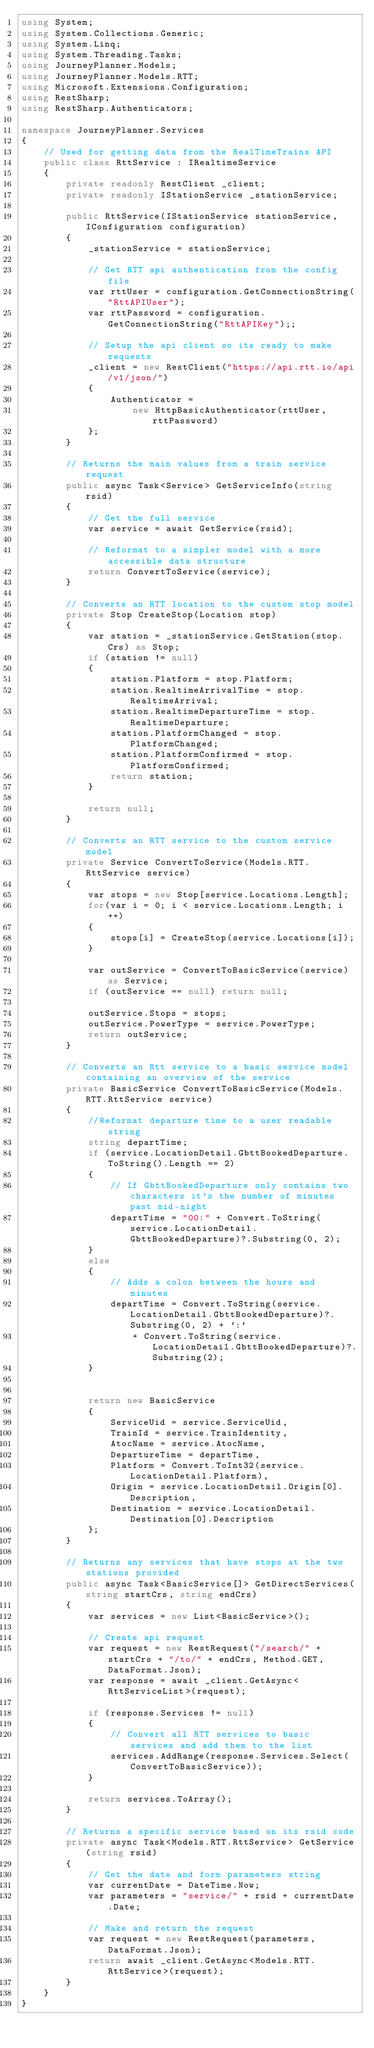Convert code to text. <code><loc_0><loc_0><loc_500><loc_500><_C#_>using System;
using System.Collections.Generic;
using System.Linq;
using System.Threading.Tasks;
using JourneyPlanner.Models;
using JourneyPlanner.Models.RTT;
using Microsoft.Extensions.Configuration;
using RestSharp;
using RestSharp.Authenticators;

namespace JourneyPlanner.Services
{
    // Used for getting data from the RealTimeTrains API
    public class RttService : IRealtimeService
    {
        private readonly RestClient _client;
        private readonly IStationService _stationService;

        public RttService(IStationService stationService, IConfiguration configuration)
        {
            _stationService = stationService;
            
            // Get RTT api authentication from the config file
            var rttUser = configuration.GetConnectionString("RttAPIUser");
            var rttPassword = configuration.GetConnectionString("RttAPIKey");;
            
            // Setup the api client so its ready to make requests
            _client = new RestClient("https://api.rtt.io/api/v1/json/")
            {
                Authenticator =
                    new HttpBasicAuthenticator(rttUser, rttPassword)
            };
        }

        // Returns the main values from a train service request
        public async Task<Service> GetServiceInfo(string rsid)
        {
            // Get the full service
            var service = await GetService(rsid);
            
            // Reformat to a simpler model with a more accessible data structure
            return ConvertToService(service);
        }

        // Converts an RTT location to the custom stop model
        private Stop CreateStop(Location stop)
        {
            var station = _stationService.GetStation(stop.Crs) as Stop;
            if (station != null)
            {
                station.Platform = stop.Platform;
                station.RealtimeArrivalTime = stop.RealtimeArrival;
                station.RealtimeDepartureTime = stop.RealtimeDeparture;
                station.PlatformChanged = stop.PlatformChanged;
                station.PlatformConfirmed = stop.PlatformConfirmed;
                return station;
            }

            return null;
        }

        // Converts an RTT service to the custom service model
        private Service ConvertToService(Models.RTT.RttService service)
        {
            var stops = new Stop[service.Locations.Length];
            for(var i = 0; i < service.Locations.Length; i++)
            {
                stops[i] = CreateStop(service.Locations[i]);
            }

            var outService = ConvertToBasicService(service) as Service;
            if (outService == null) return null;
            
            outService.Stops = stops;
            outService.PowerType = service.PowerType;
            return outService;
        }

        // Converts an Rtt service to a basic service model containing an overview of the service
        private BasicService ConvertToBasicService(Models.RTT.RttService service)
        {
            //Reformat departure time to a user readable string
            string departTime;
            if (service.LocationDetail.GbttBookedDeparture.ToString().Length == 2)
            {
                // If GbttBookedDeparture only contains two characters it's the number of minutes past mid-night
                departTime = "00:" + Convert.ToString(service.LocationDetail.GbttBookedDeparture)?.Substring(0, 2);
            }
            else
            {
                // Adds a colon between the hours and minutes
                departTime = Convert.ToString(service.LocationDetail.GbttBookedDeparture)?.Substring(0, 2) + ':' 
                    + Convert.ToString(service.LocationDetail.GbttBookedDeparture)?.Substring(2);
            }
            
            
            return new BasicService
            {
                ServiceUid = service.ServiceUid, 
                TrainId = service.TrainIdentity,
                AtocName = service.AtocName, 
                DepartureTime = departTime,
                Platform = Convert.ToInt32(service.LocationDetail.Platform),
                Origin = service.LocationDetail.Origin[0].Description,
                Destination = service.LocationDetail.Destination[0].Description
            };
        }

        // Returns any services that have stops at the two stations provided
        public async Task<BasicService[]> GetDirectServices(string startCrs, string endCrs)
        {
            var services = new List<BasicService>();
            
            // Create api request
            var request = new RestRequest("/search/" + startCrs + "/to/" + endCrs, Method.GET, DataFormat.Json);
            var response = await _client.GetAsync<RttServiceList>(request);

            if (response.Services != null)
            {
                // Convert all RTT services to basic services and add them to the list
                services.AddRange(response.Services.Select(ConvertToBasicService));
            }
            
            return services.ToArray();
        }
        
        // Returns a specific service based on its rsid code
        private async Task<Models.RTT.RttService> GetService(string rsid)
        {
            // Get the date and form parameters string
            var currentDate = DateTime.Now;
            var parameters = "service/" + rsid + currentDate.Date;
            
            // Make and return the request
            var request = new RestRequest(parameters, DataFormat.Json);
            return await _client.GetAsync<Models.RTT.RttService>(request);
        }
    }
}
</code> 